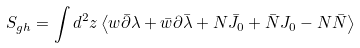Convert formula to latex. <formula><loc_0><loc_0><loc_500><loc_500>S _ { g h } = \int d ^ { 2 } z \left \langle w \bar { \partial } \lambda + \bar { w } \partial \bar { \lambda } + N \bar { J } _ { 0 } + \bar { N } J _ { 0 } - N \bar { N } \right \rangle</formula> 